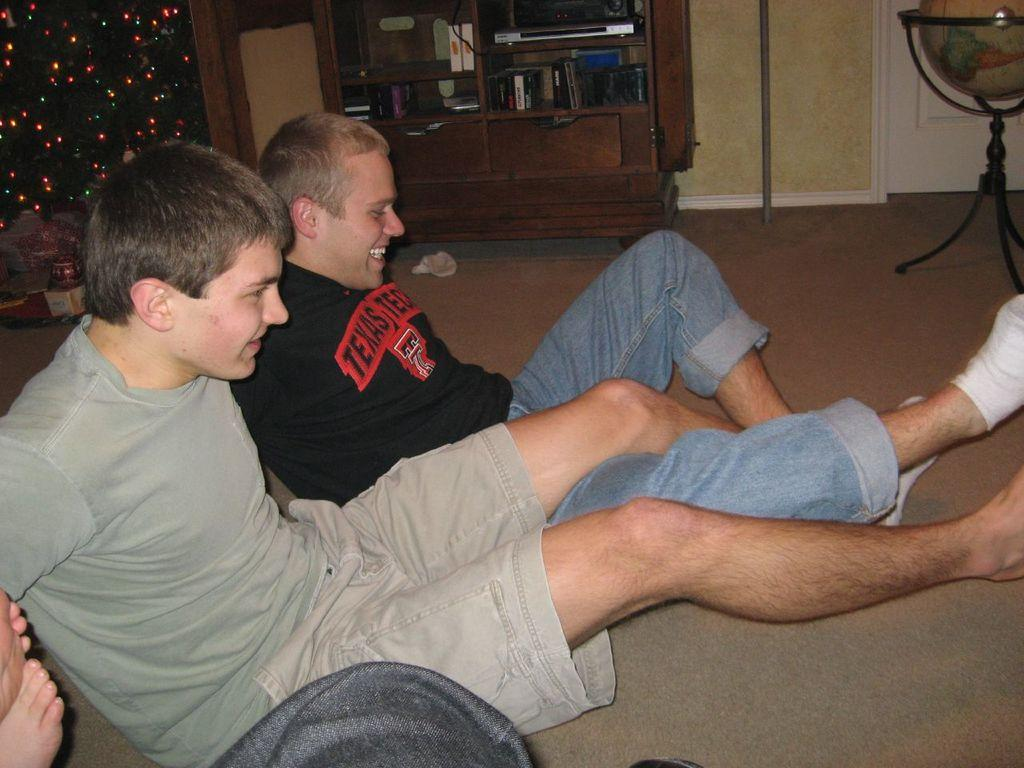Provide a one-sentence caption for the provided image. A man with a black sirt and red test that reads, "Texas." wrestles legs with a man next to him. 